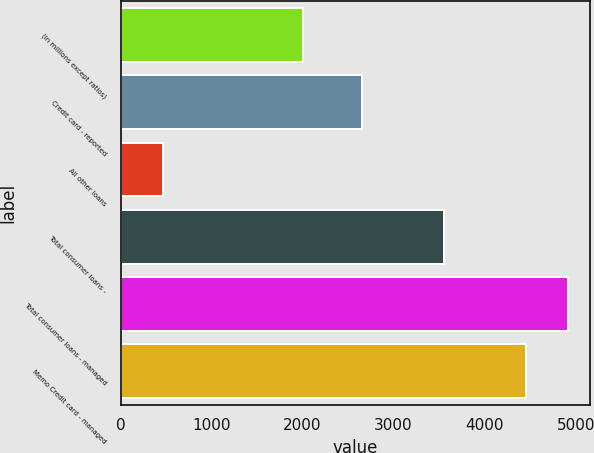Convert chart. <chart><loc_0><loc_0><loc_500><loc_500><bar_chart><fcel>(in millions except ratios)<fcel>Credit card - reported<fcel>All other loans<fcel>Total consumer loans -<fcel>Total consumer loans - managed<fcel>Memo Credit card - managed<nl><fcel>2008<fcel>2649<fcel>463<fcel>3557.1<fcel>4914<fcel>4451<nl></chart> 